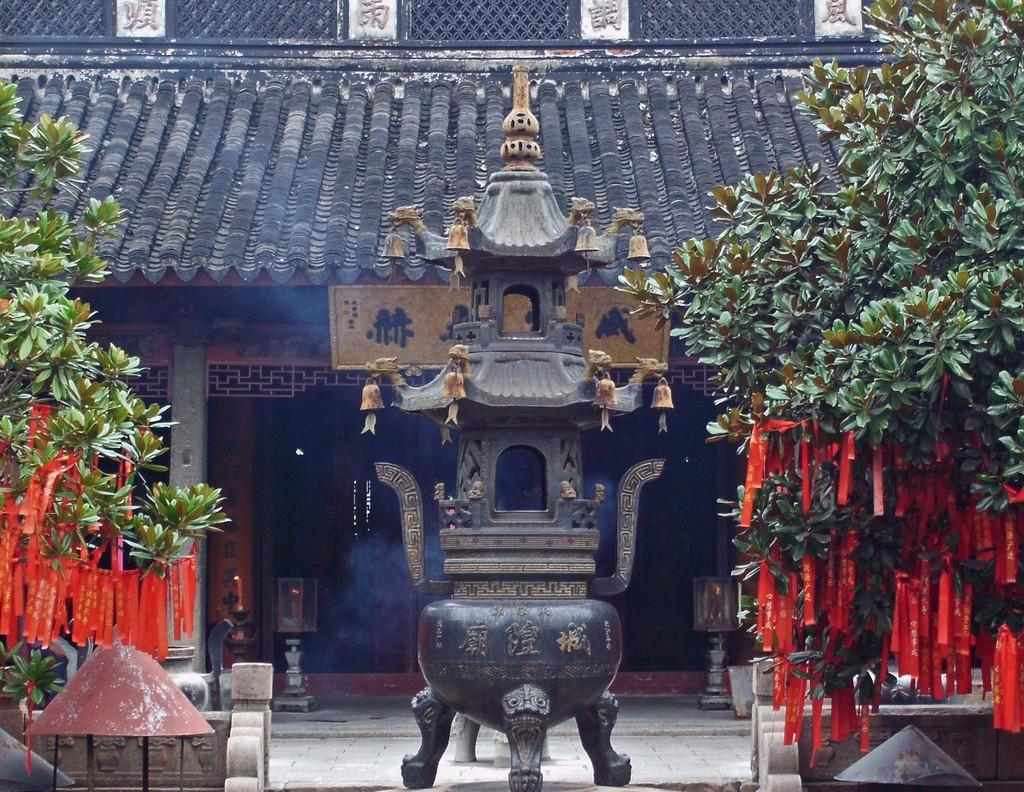What is the main subject in the middle of the image? There is a sculpture in the middle of the image. What can be seen on the left side of the image? There are trees on the left side of the image. What can be seen on the right side of the image? There are trees on the right side of the image. What is visible in the background of the image? There is a house in the background of the image. What type of texture can be felt on the foot of the sculpture in the image? There is no mention of a foot or texture on the sculpture in the image, so it cannot be determined from the provided facts. 